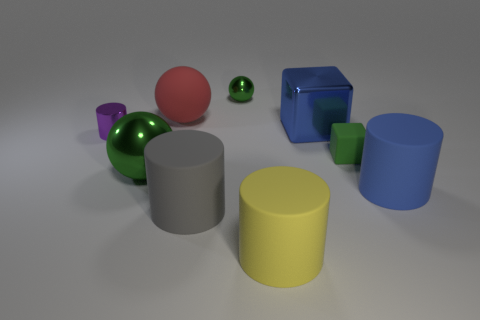Is the color of the large cube the same as the cylinder to the left of the big green metallic object?
Your response must be concise. No. Is the number of big yellow cylinders less than the number of small purple shiny blocks?
Your response must be concise. No. Is the number of shiny things right of the tiny green matte block greater than the number of spheres that are behind the purple cylinder?
Provide a short and direct response. No. Do the red object and the blue block have the same material?
Your answer should be compact. No. There is a green metal object in front of the tiny cylinder; how many tiny purple things are in front of it?
Give a very brief answer. 0. Does the tiny object behind the red matte thing have the same color as the shiny cylinder?
Provide a short and direct response. No. What number of things are either purple cylinders or large spheres on the right side of the big green shiny object?
Make the answer very short. 2. There is a rubber thing to the right of the tiny rubber block; is it the same shape as the small metallic object behind the big blue block?
Ensure brevity in your answer.  No. Are there any other things that are the same color as the matte block?
Keep it short and to the point. Yes. The blue thing that is made of the same material as the big green ball is what shape?
Provide a short and direct response. Cube. 